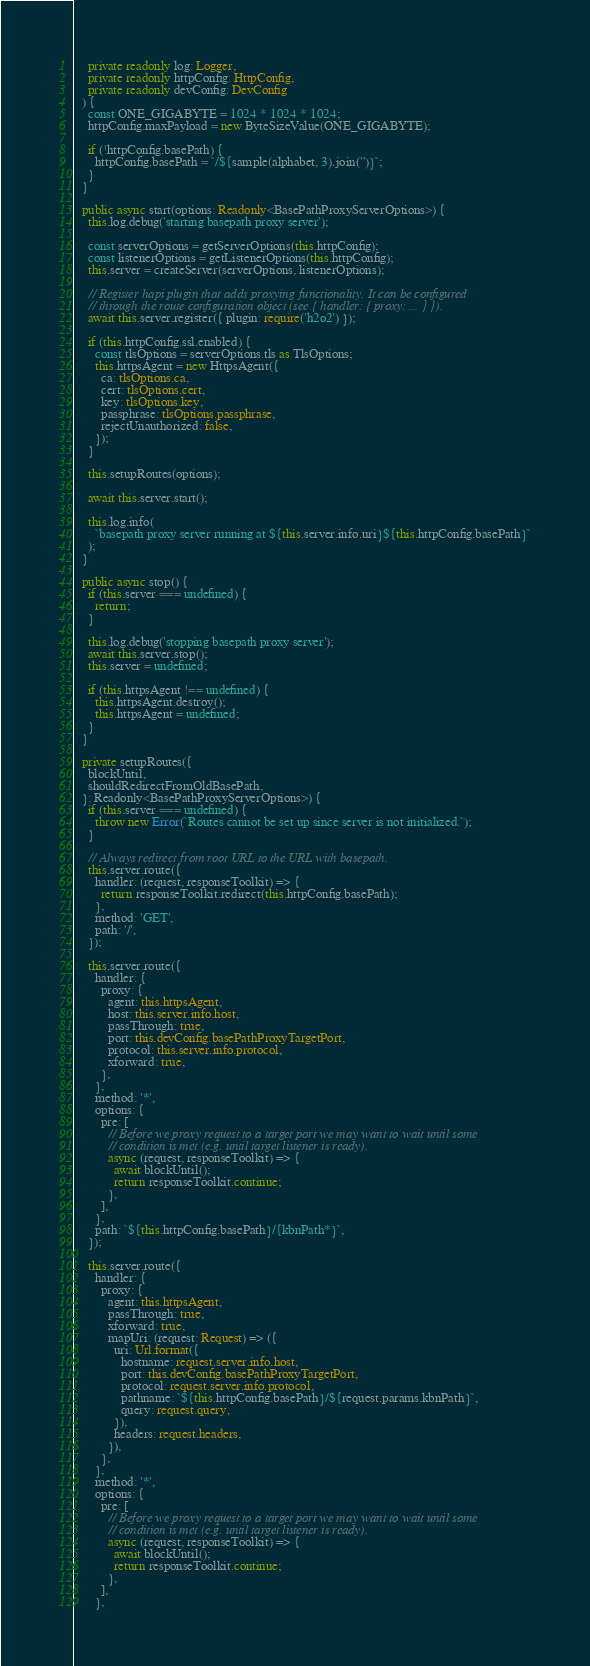<code> <loc_0><loc_0><loc_500><loc_500><_TypeScript_>    private readonly log: Logger,
    private readonly httpConfig: HttpConfig,
    private readonly devConfig: DevConfig
  ) {
    const ONE_GIGABYTE = 1024 * 1024 * 1024;
    httpConfig.maxPayload = new ByteSizeValue(ONE_GIGABYTE);

    if (!httpConfig.basePath) {
      httpConfig.basePath = `/${sample(alphabet, 3).join('')}`;
    }
  }

  public async start(options: Readonly<BasePathProxyServerOptions>) {
    this.log.debug('starting basepath proxy server');

    const serverOptions = getServerOptions(this.httpConfig);
    const listenerOptions = getListenerOptions(this.httpConfig);
    this.server = createServer(serverOptions, listenerOptions);

    // Register hapi plugin that adds proxying functionality. It can be configured
    // through the route configuration object (see { handler: { proxy: ... } }).
    await this.server.register({ plugin: require('h2o2') });

    if (this.httpConfig.ssl.enabled) {
      const tlsOptions = serverOptions.tls as TlsOptions;
      this.httpsAgent = new HttpsAgent({
        ca: tlsOptions.ca,
        cert: tlsOptions.cert,
        key: tlsOptions.key,
        passphrase: tlsOptions.passphrase,
        rejectUnauthorized: false,
      });
    }

    this.setupRoutes(options);

    await this.server.start();

    this.log.info(
      `basepath proxy server running at ${this.server.info.uri}${this.httpConfig.basePath}`
    );
  }

  public async stop() {
    if (this.server === undefined) {
      return;
    }

    this.log.debug('stopping basepath proxy server');
    await this.server.stop();
    this.server = undefined;

    if (this.httpsAgent !== undefined) {
      this.httpsAgent.destroy();
      this.httpsAgent = undefined;
    }
  }

  private setupRoutes({
    blockUntil,
    shouldRedirectFromOldBasePath,
  }: Readonly<BasePathProxyServerOptions>) {
    if (this.server === undefined) {
      throw new Error(`Routes cannot be set up since server is not initialized.`);
    }

    // Always redirect from root URL to the URL with basepath.
    this.server.route({
      handler: (request, responseToolkit) => {
        return responseToolkit.redirect(this.httpConfig.basePath);
      },
      method: 'GET',
      path: '/',
    });

    this.server.route({
      handler: {
        proxy: {
          agent: this.httpsAgent,
          host: this.server.info.host,
          passThrough: true,
          port: this.devConfig.basePathProxyTargetPort,
          protocol: this.server.info.protocol,
          xforward: true,
        },
      },
      method: '*',
      options: {
        pre: [
          // Before we proxy request to a target port we may want to wait until some
          // condition is met (e.g. until target listener is ready).
          async (request, responseToolkit) => {
            await blockUntil();
            return responseToolkit.continue;
          },
        ],
      },
      path: `${this.httpConfig.basePath}/{kbnPath*}`,
    });

    this.server.route({
      handler: {
        proxy: {
          agent: this.httpsAgent,
          passThrough: true,
          xforward: true,
          mapUri: (request: Request) => ({
            uri: Url.format({
              hostname: request.server.info.host,
              port: this.devConfig.basePathProxyTargetPort,
              protocol: request.server.info.protocol,
              pathname: `${this.httpConfig.basePath}/${request.params.kbnPath}`,
              query: request.query,
            }),
            headers: request.headers,
          }),
        },
      },
      method: '*',
      options: {
        pre: [
          // Before we proxy request to a target port we may want to wait until some
          // condition is met (e.g. until target listener is ready).
          async (request, responseToolkit) => {
            await blockUntil();
            return responseToolkit.continue;
          },
        ],
      },</code> 